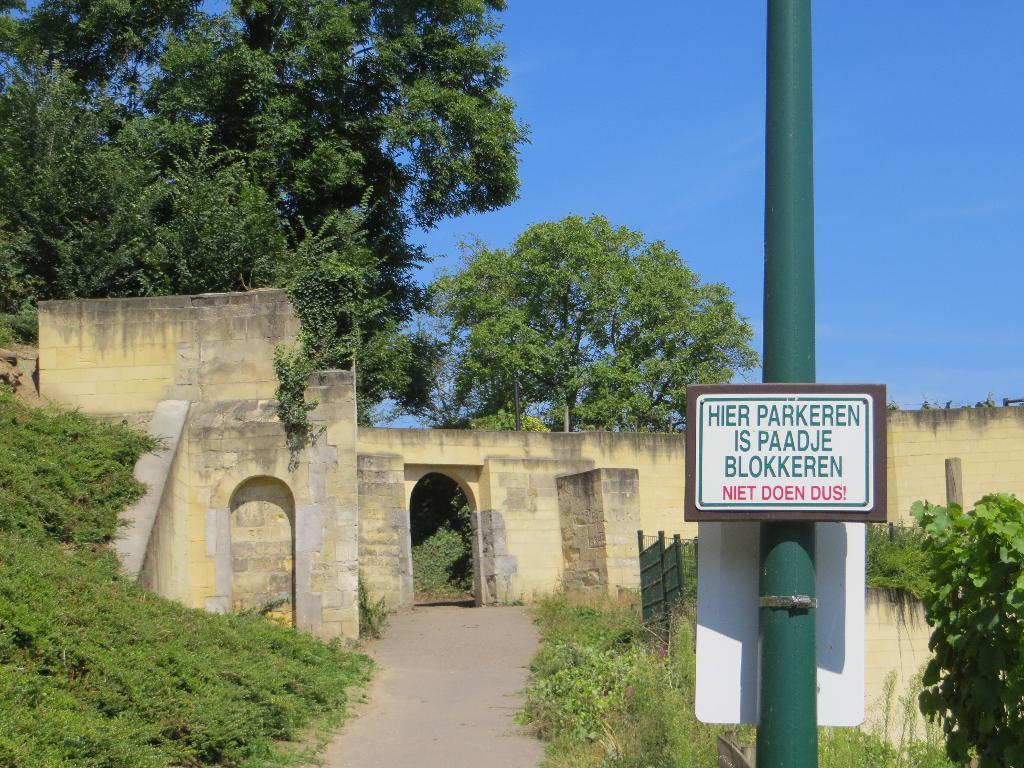What type of structure can be seen in the image? There is a wall in the image. What is attached to the wall in the image? There is a pole with words in the image. What type of vegetation is present in the image? There are plants in the image. What can be seen in the background of the image? There are trees and the sky visible in the background of the image. How many times does the plant burst in the image? There is no plant bursting in the image; the plants are stationary. 